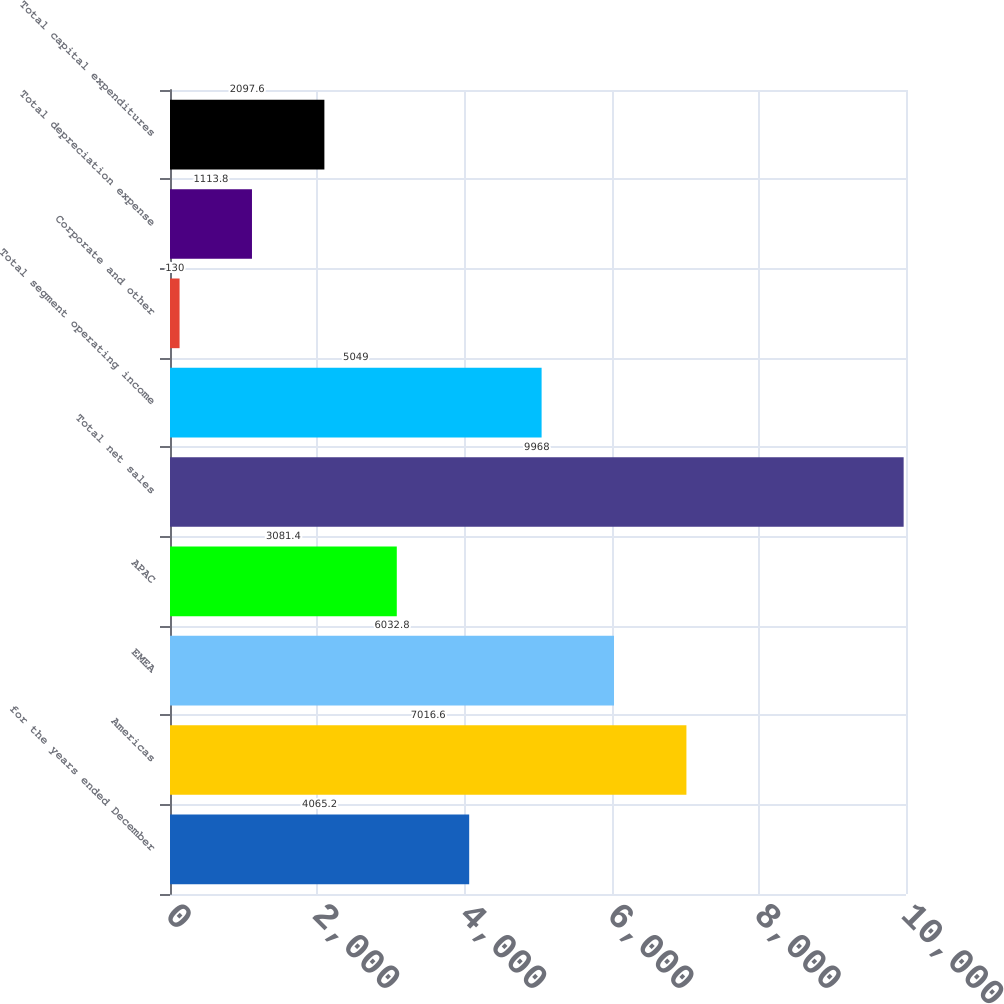<chart> <loc_0><loc_0><loc_500><loc_500><bar_chart><fcel>for the years ended December<fcel>Americas<fcel>EMEA<fcel>APAC<fcel>Total net sales<fcel>Total segment operating income<fcel>Corporate and other<fcel>Total depreciation expense<fcel>Total capital expenditures<nl><fcel>4065.2<fcel>7016.6<fcel>6032.8<fcel>3081.4<fcel>9968<fcel>5049<fcel>130<fcel>1113.8<fcel>2097.6<nl></chart> 